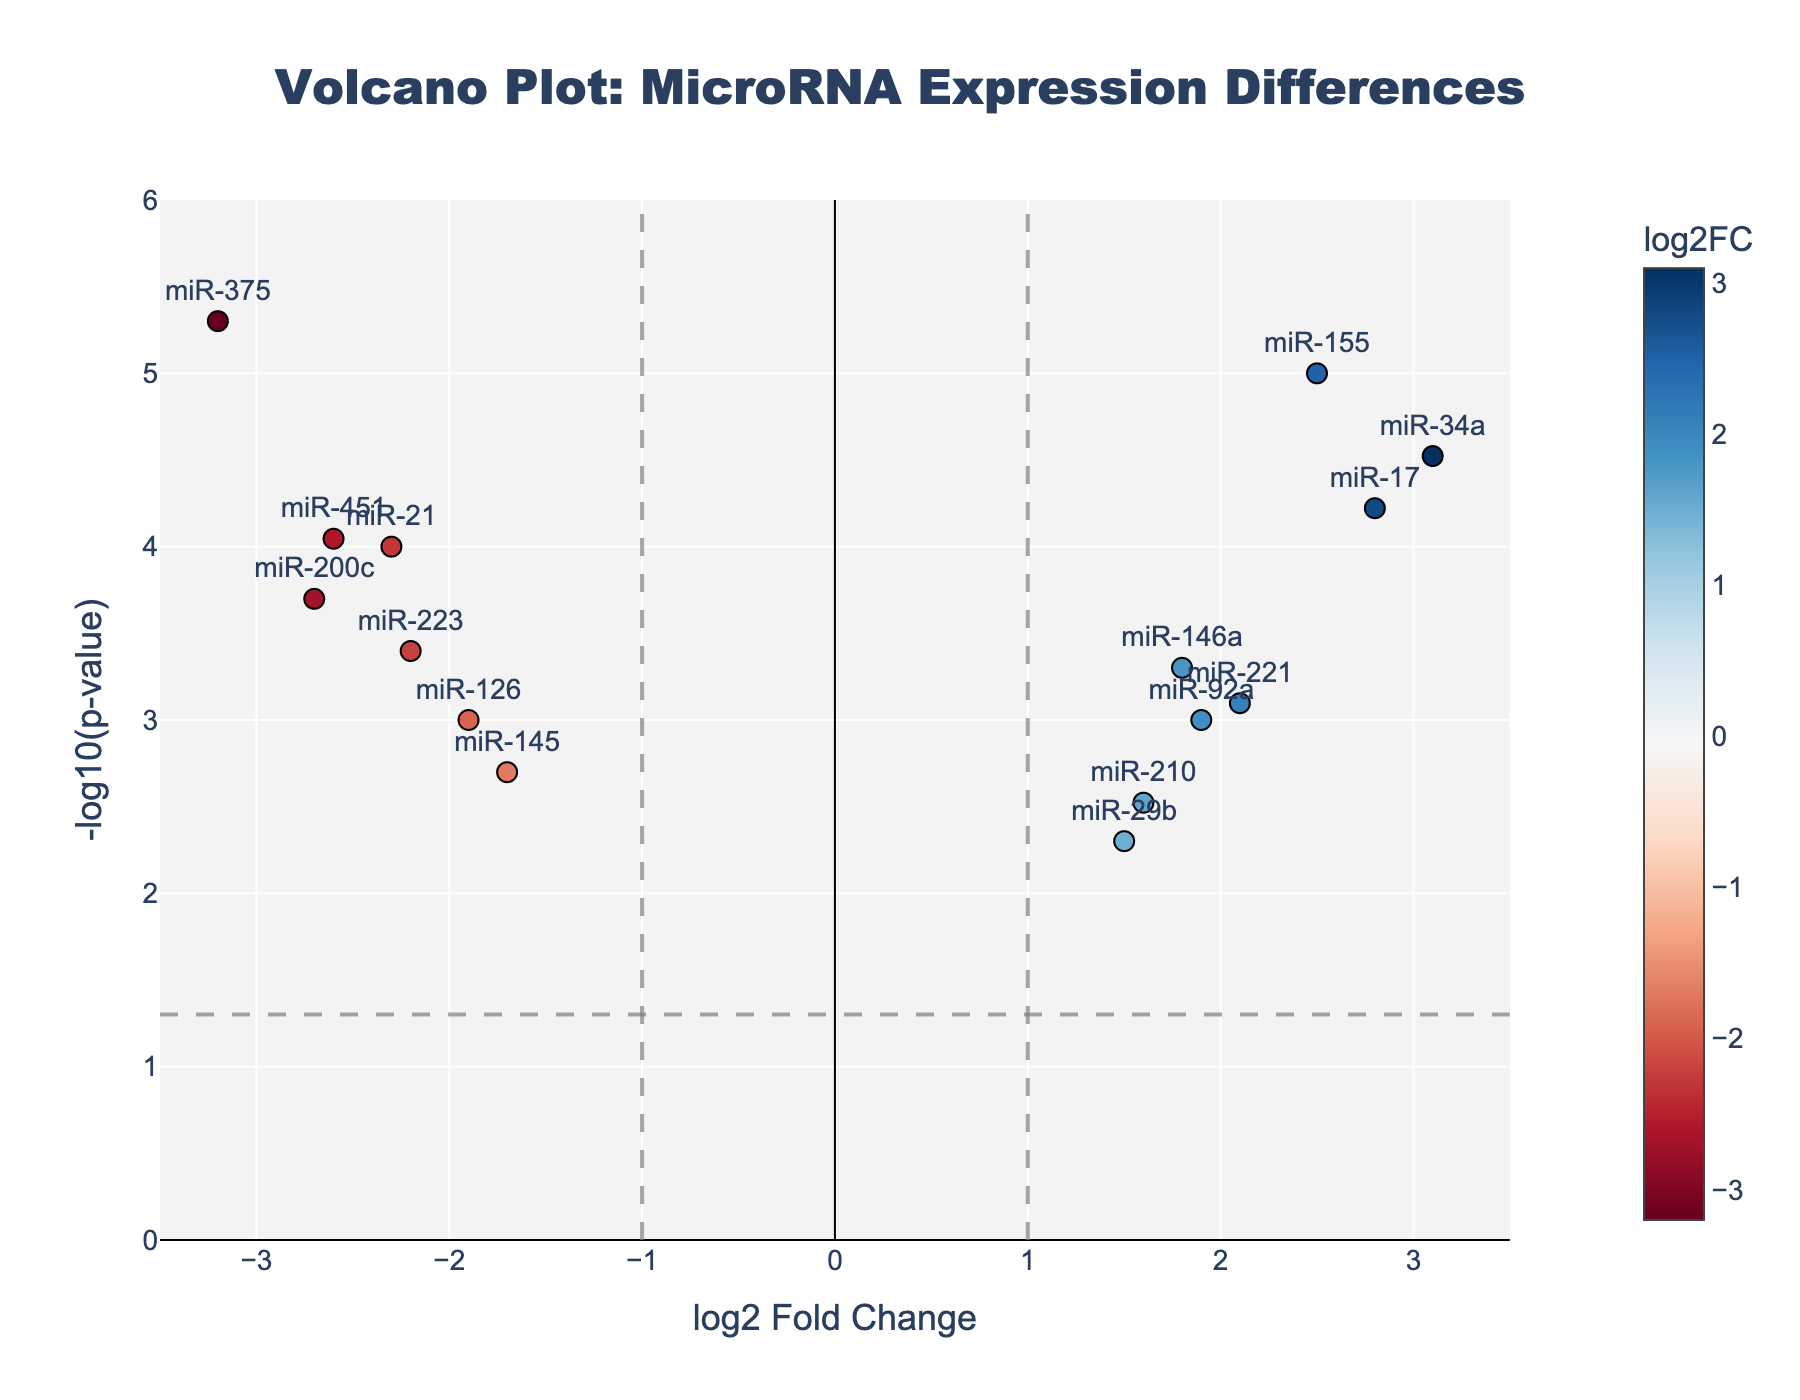What is the title of the plot? The title is usually found at the top center of the plot. It states, "Volcano Plot: MicroRNA Expression Differences".
Answer: Volcano Plot: MicroRNA Expression Differences What are the x-axis and y-axis labels? The axes labels are typically found next to the axes. The x-axis is labeled as "log2 Fold Change" and the y-axis is labeled as "-log10(p-value)".
Answer: log2 Fold Change; -log10(p-value) How many miRNAs have a log2FoldChange greater than 2? Looking at the x-axis value of 2 and observing the miRNAs to the right, there are three miRNAs: miR-155, miR-34a, and miR-17.
Answer: 3 Which miRNA has the highest -log10(p-value)? The -log10(p-value) is on the y-axis. The miRNA with the highest point along the y-axis is miR-375.
Answer: miR-375 What colors are used in the plot? The colors are derived from a colorscale that ranges from blue (negative values) to red (positive values). The central axis is marked with black lines.
Answer: Blue to red Which miRNA has the most negative log2FoldChange? The miRNA with the smallest value on the x-axis is miR-375, located at -3.2.
Answer: miR-375 Are there more upregulated (positive log2FoldChange) or downregulated (negative log2FoldChange) miRNAs? By counting, there are more miRNAs with positive log2FoldChange (8) compared to those with negative log2FoldChange (7).
Answer: Upregulated Which miRNA has nearly equal contributions from both axes? The miRNA very close to both the -1 on the x-axis and around the mid-range on the y-axis is miR-145.
Answer: miR-145 What is the significance threshold indicated by the horizontal line on the y-axis? The value of the horizontal line intersecting the y-axis can be read as -log10(0.05), approximately 1.301.
Answer: 1.301 Which miRNAs are considered statistically significant if we use the threshold of -log10(p-value) > 1.301? The miRNAs above the horizontal line (>1.301) include miR-21, miR-146a, miR-155, miR-126, miR-34a, miR-200c, miR-375, miR-221, miR-17, miR-210, miR-223, miR-92a, and miR-451.
Answer: miR-21, miR-146a, miR-155, miR-126, miR-34a, miR-200c, miR-375, miR-221, miR-17, miR-210, miR-223, miR-92a, miR-451 